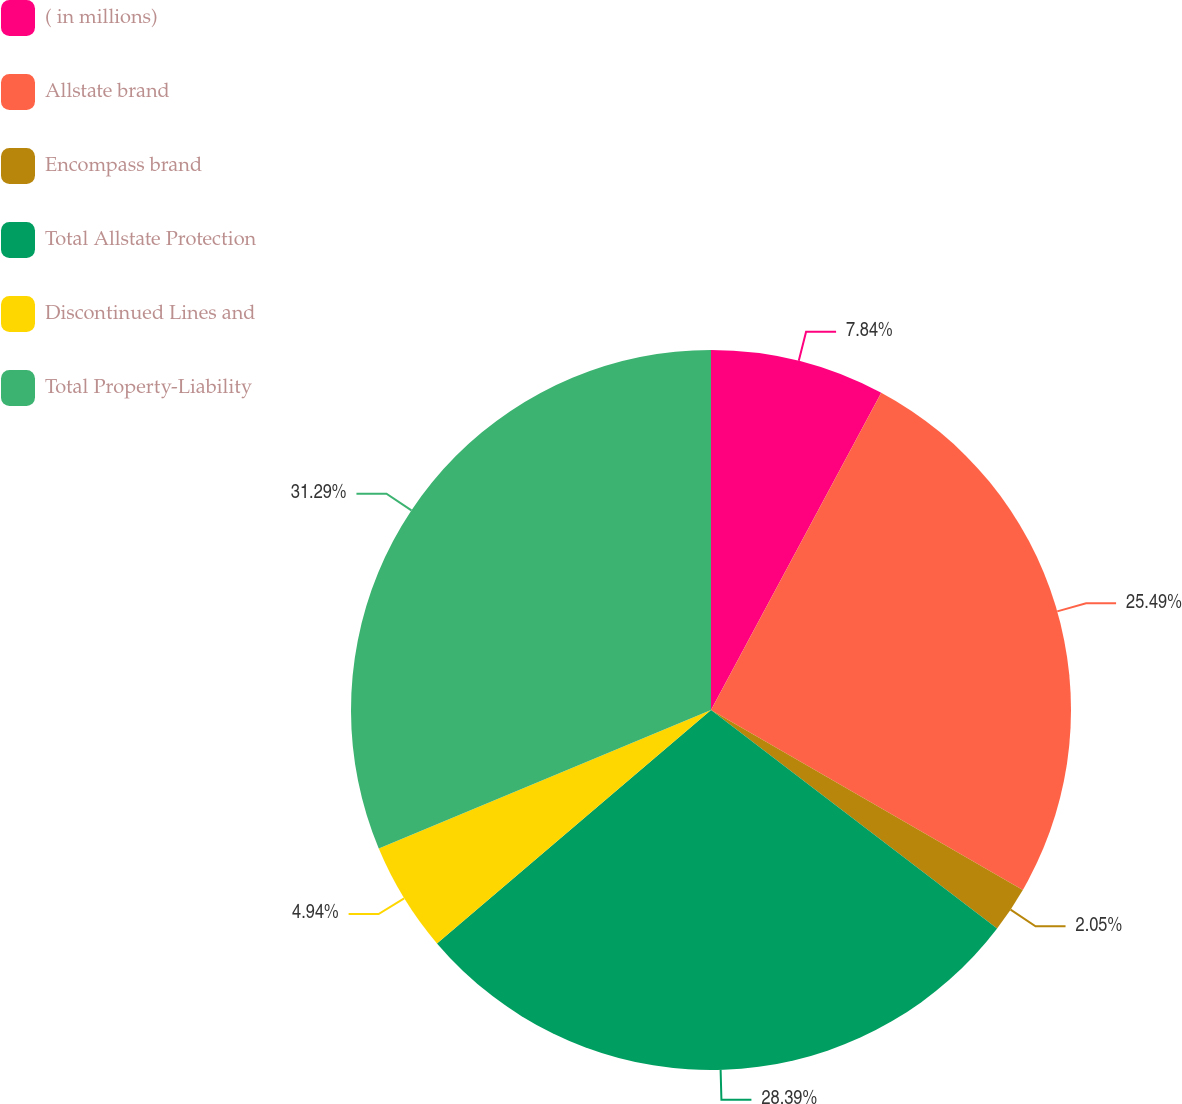Convert chart. <chart><loc_0><loc_0><loc_500><loc_500><pie_chart><fcel>( in millions)<fcel>Allstate brand<fcel>Encompass brand<fcel>Total Allstate Protection<fcel>Discontinued Lines and<fcel>Total Property-Liability<nl><fcel>7.84%<fcel>25.49%<fcel>2.05%<fcel>28.39%<fcel>4.94%<fcel>31.29%<nl></chart> 